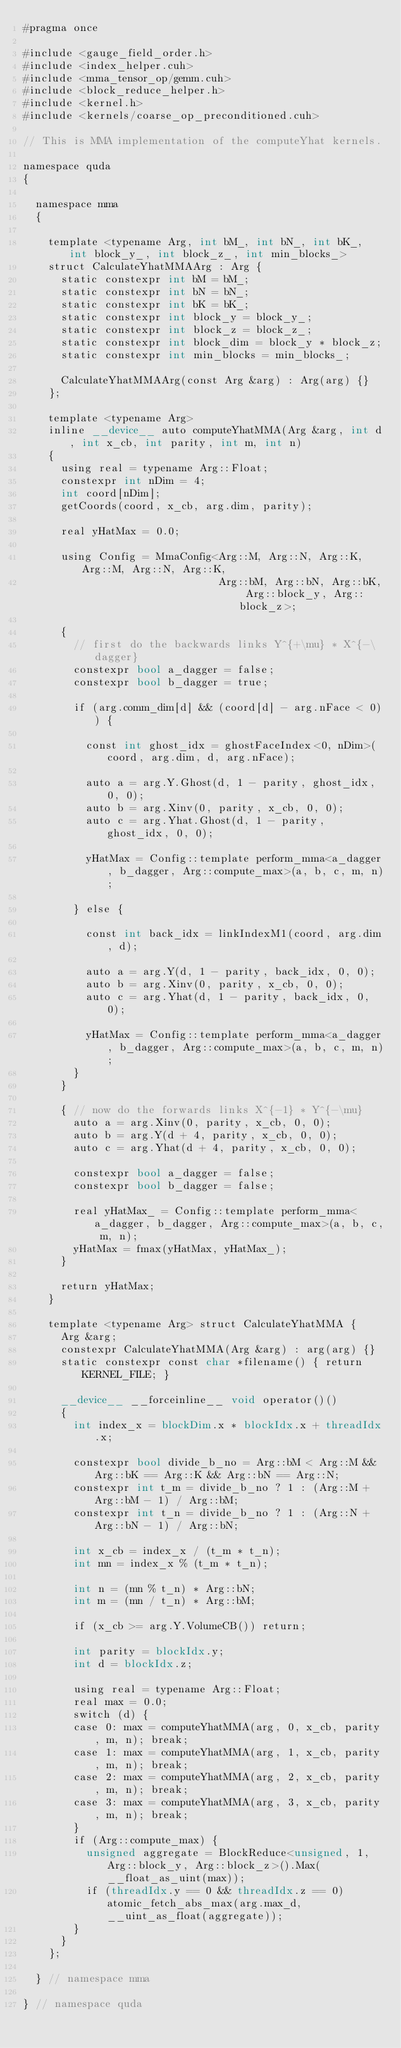Convert code to text. <code><loc_0><loc_0><loc_500><loc_500><_Cuda_>#pragma once

#include <gauge_field_order.h>
#include <index_helper.cuh>
#include <mma_tensor_op/gemm.cuh>
#include <block_reduce_helper.h>
#include <kernel.h>
#include <kernels/coarse_op_preconditioned.cuh>

// This is MMA implementation of the computeYhat kernels.

namespace quda
{

  namespace mma
  {

    template <typename Arg, int bM_, int bN_, int bK_, int block_y_, int block_z_, int min_blocks_>
    struct CalculateYhatMMAArg : Arg {
      static constexpr int bM = bM_;
      static constexpr int bN = bN_;
      static constexpr int bK = bK_;
      static constexpr int block_y = block_y_;
      static constexpr int block_z = block_z_;
      static constexpr int block_dim = block_y * block_z;
      static constexpr int min_blocks = min_blocks_;

      CalculateYhatMMAArg(const Arg &arg) : Arg(arg) {}
    };

    template <typename Arg>
    inline __device__ auto computeYhatMMA(Arg &arg, int d, int x_cb, int parity, int m, int n)
    {
      using real = typename Arg::Float;
      constexpr int nDim = 4;
      int coord[nDim];
      getCoords(coord, x_cb, arg.dim, parity);

      real yHatMax = 0.0;

      using Config = MmaConfig<Arg::M, Arg::N, Arg::K, Arg::M, Arg::N, Arg::K,
                               Arg::bM, Arg::bN, Arg::bK, Arg::block_y, Arg::block_z>;

      {
        // first do the backwards links Y^{+\mu} * X^{-\dagger}
        constexpr bool a_dagger = false;
        constexpr bool b_dagger = true;

        if (arg.comm_dim[d] && (coord[d] - arg.nFace < 0)) {

          const int ghost_idx = ghostFaceIndex<0, nDim>(coord, arg.dim, d, arg.nFace);

          auto a = arg.Y.Ghost(d, 1 - parity, ghost_idx, 0, 0);
          auto b = arg.Xinv(0, parity, x_cb, 0, 0);
          auto c = arg.Yhat.Ghost(d, 1 - parity, ghost_idx, 0, 0);

          yHatMax = Config::template perform_mma<a_dagger, b_dagger, Arg::compute_max>(a, b, c, m, n);

        } else {

          const int back_idx = linkIndexM1(coord, arg.dim, d);

          auto a = arg.Y(d, 1 - parity, back_idx, 0, 0);
          auto b = arg.Xinv(0, parity, x_cb, 0, 0);
          auto c = arg.Yhat(d, 1 - parity, back_idx, 0, 0);

          yHatMax = Config::template perform_mma<a_dagger, b_dagger, Arg::compute_max>(a, b, c, m, n);
        }
      }

      { // now do the forwards links X^{-1} * Y^{-\mu}
        auto a = arg.Xinv(0, parity, x_cb, 0, 0);
        auto b = arg.Y(d + 4, parity, x_cb, 0, 0);
        auto c = arg.Yhat(d + 4, parity, x_cb, 0, 0);

        constexpr bool a_dagger = false;
        constexpr bool b_dagger = false;

        real yHatMax_ = Config::template perform_mma<a_dagger, b_dagger, Arg::compute_max>(a, b, c, m, n);
        yHatMax = fmax(yHatMax, yHatMax_);
      }

      return yHatMax;
    }

    template <typename Arg> struct CalculateYhatMMA {
      Arg &arg;
      constexpr CalculateYhatMMA(Arg &arg) : arg(arg) {}
      static constexpr const char *filename() { return KERNEL_FILE; }

      __device__ __forceinline__ void operator()()
      {
        int index_x = blockDim.x * blockIdx.x + threadIdx.x;

        constexpr bool divide_b_no = Arg::bM < Arg::M && Arg::bK == Arg::K && Arg::bN == Arg::N;
        constexpr int t_m = divide_b_no ? 1 : (Arg::M + Arg::bM - 1) / Arg::bM;
        constexpr int t_n = divide_b_no ? 1 : (Arg::N + Arg::bN - 1) / Arg::bN;

        int x_cb = index_x / (t_m * t_n);
        int mn = index_x % (t_m * t_n);

        int n = (mn % t_n) * Arg::bN;
        int m = (mn / t_n) * Arg::bM;

        if (x_cb >= arg.Y.VolumeCB()) return;

        int parity = blockIdx.y;
        int d = blockIdx.z;

        using real = typename Arg::Float;
        real max = 0.0;
        switch (d) {
        case 0: max = computeYhatMMA(arg, 0, x_cb, parity, m, n); break;
        case 1: max = computeYhatMMA(arg, 1, x_cb, parity, m, n); break;
        case 2: max = computeYhatMMA(arg, 2, x_cb, parity, m, n); break;
        case 3: max = computeYhatMMA(arg, 3, x_cb, parity, m, n); break;
        }
        if (Arg::compute_max) {
          unsigned aggregate = BlockReduce<unsigned, 1, Arg::block_y, Arg::block_z>().Max(__float_as_uint(max));
          if (threadIdx.y == 0 && threadIdx.z == 0) atomic_fetch_abs_max(arg.max_d, __uint_as_float(aggregate));
        }
      }
    };

  } // namespace mma

} // namespace quda
</code> 